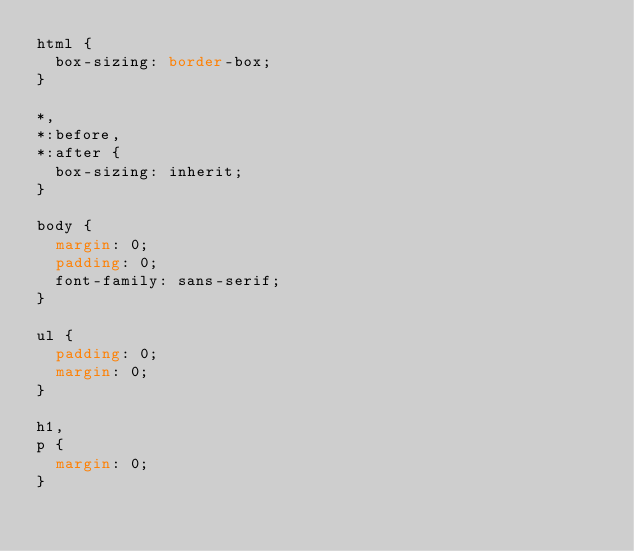<code> <loc_0><loc_0><loc_500><loc_500><_CSS_>html {
  box-sizing: border-box;
}

*,
*:before,
*:after {
  box-sizing: inherit;
}

body {
  margin: 0;
  padding: 0;
  font-family: sans-serif;
}

ul {
  padding: 0;
  margin: 0;
}

h1,
p {
  margin: 0;
}
</code> 